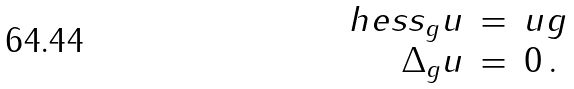Convert formula to latex. <formula><loc_0><loc_0><loc_500><loc_500>\begin{array} { r c l } \ h e s s _ { g } u & = & u g \\ \Delta _ { g } u & = & 0 \, . \end{array}</formula> 